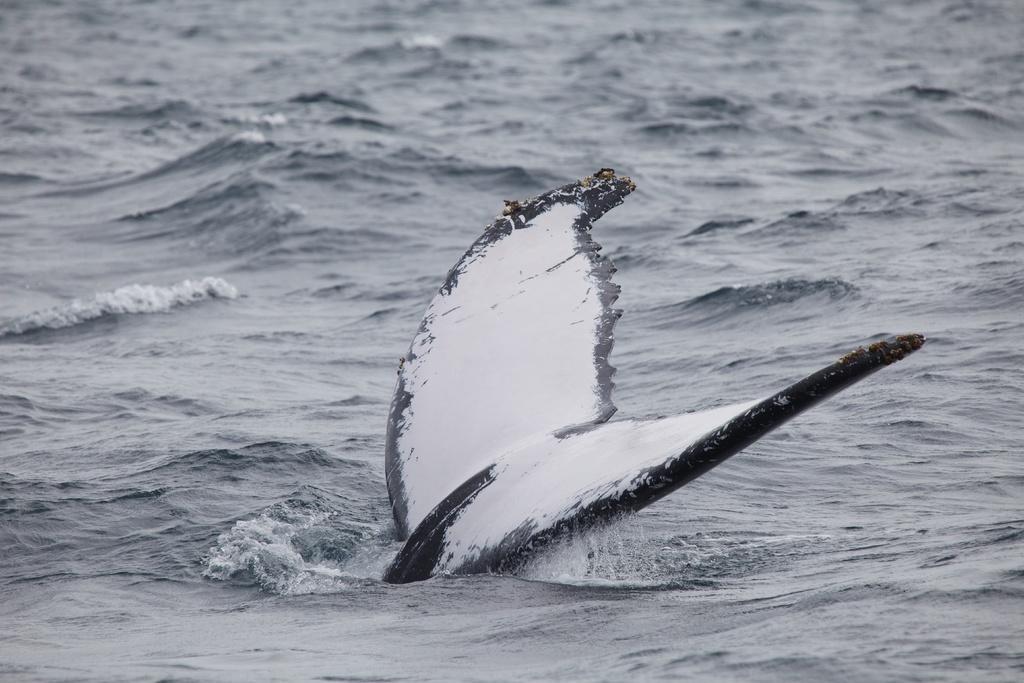Describe this image in one or two sentences. In this picture we can see an object and in the background we can see water. 